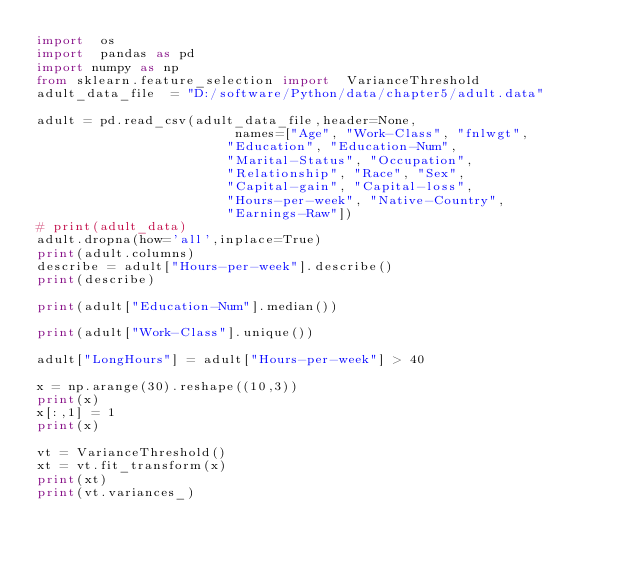<code> <loc_0><loc_0><loc_500><loc_500><_Python_>import  os
import  pandas as pd
import numpy as np
from sklearn.feature_selection import  VarianceThreshold
adult_data_file  = "D:/software/Python/data/chapter5/adult.data"

adult = pd.read_csv(adult_data_file,header=None,
                         names=["Age", "Work-Class", "fnlwgt",
                        "Education", "Education-Num",
                        "Marital-Status", "Occupation",
                        "Relationship", "Race", "Sex",
                        "Capital-gain", "Capital-loss",
                        "Hours-per-week", "Native-Country",
                        "Earnings-Raw"])
# print(adult_data)
adult.dropna(how='all',inplace=True)
print(adult.columns)
describe = adult["Hours-per-week"].describe()
print(describe)

print(adult["Education-Num"].median())

print(adult["Work-Class"].unique())

adult["LongHours"] = adult["Hours-per-week"] > 40

x = np.arange(30).reshape((10,3))
print(x)
x[:,1] = 1
print(x)

vt = VarianceThreshold()
xt = vt.fit_transform(x)
print(xt)
print(vt.variances_)</code> 